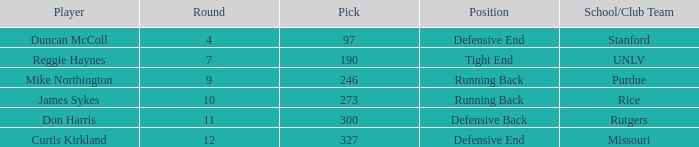What is the total number of rounds that had draft pick 97, duncan mccoll? 0.0. 